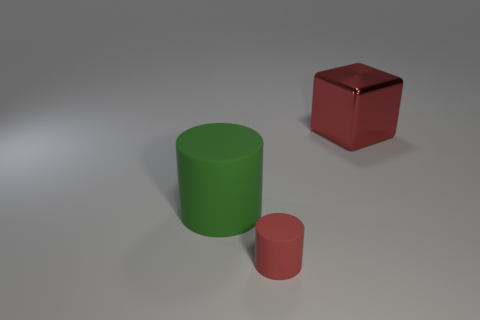Add 3 tiny blue blocks. How many objects exist? 6 Subtract all cylinders. How many objects are left? 1 Add 2 red matte cylinders. How many red matte cylinders are left? 3 Add 3 large red metal blocks. How many large red metal blocks exist? 4 Subtract 0 brown cubes. How many objects are left? 3 Subtract all green cylinders. Subtract all large green objects. How many objects are left? 1 